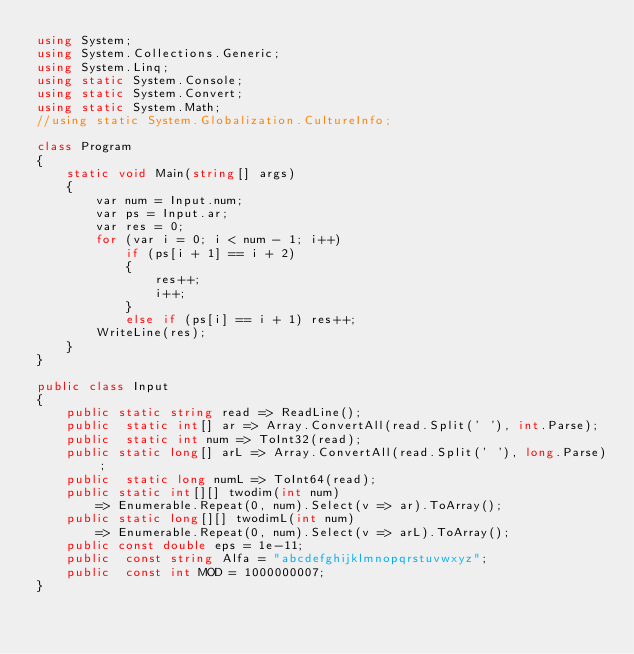<code> <loc_0><loc_0><loc_500><loc_500><_C#_>using System;
using System.Collections.Generic;
using System.Linq;
using static System.Console;
using static System.Convert;
using static System.Math;
//using static System.Globalization.CultureInfo;

class Program
{
    static void Main(string[] args)
    {
        var num = Input.num;
        var ps = Input.ar;
        var res = 0;
        for (var i = 0; i < num - 1; i++)
            if (ps[i + 1] == i + 2)
            {
                res++;
                i++;
            }
            else if (ps[i] == i + 1) res++;
        WriteLine(res);
    }
}

public class Input
{
    public static string read => ReadLine();
    public  static int[] ar => Array.ConvertAll(read.Split(' '), int.Parse);
    public  static int num => ToInt32(read);
    public static long[] arL => Array.ConvertAll(read.Split(' '), long.Parse);
    public  static long numL => ToInt64(read);
    public static int[][] twodim(int num)
        => Enumerable.Repeat(0, num).Select(v => ar).ToArray();
    public static long[][] twodimL(int num)
        => Enumerable.Repeat(0, num).Select(v => arL).ToArray();
    public const double eps = 1e-11;
    public  const string Alfa = "abcdefghijklmnopqrstuvwxyz";
    public  const int MOD = 1000000007;
}
</code> 